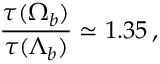<formula> <loc_0><loc_0><loc_500><loc_500>\frac { \tau ( \Omega _ { b } ) } { \tau ( \Lambda _ { b } ) } \simeq 1 . 3 5 \, ,</formula> 